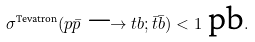Convert formula to latex. <formula><loc_0><loc_0><loc_500><loc_500>\sigma ^ { \text {Tevatron} } ( p \bar { p } \longrightarrow t b ; \bar { t } \bar { b } ) < 1 \text { pb} .</formula> 